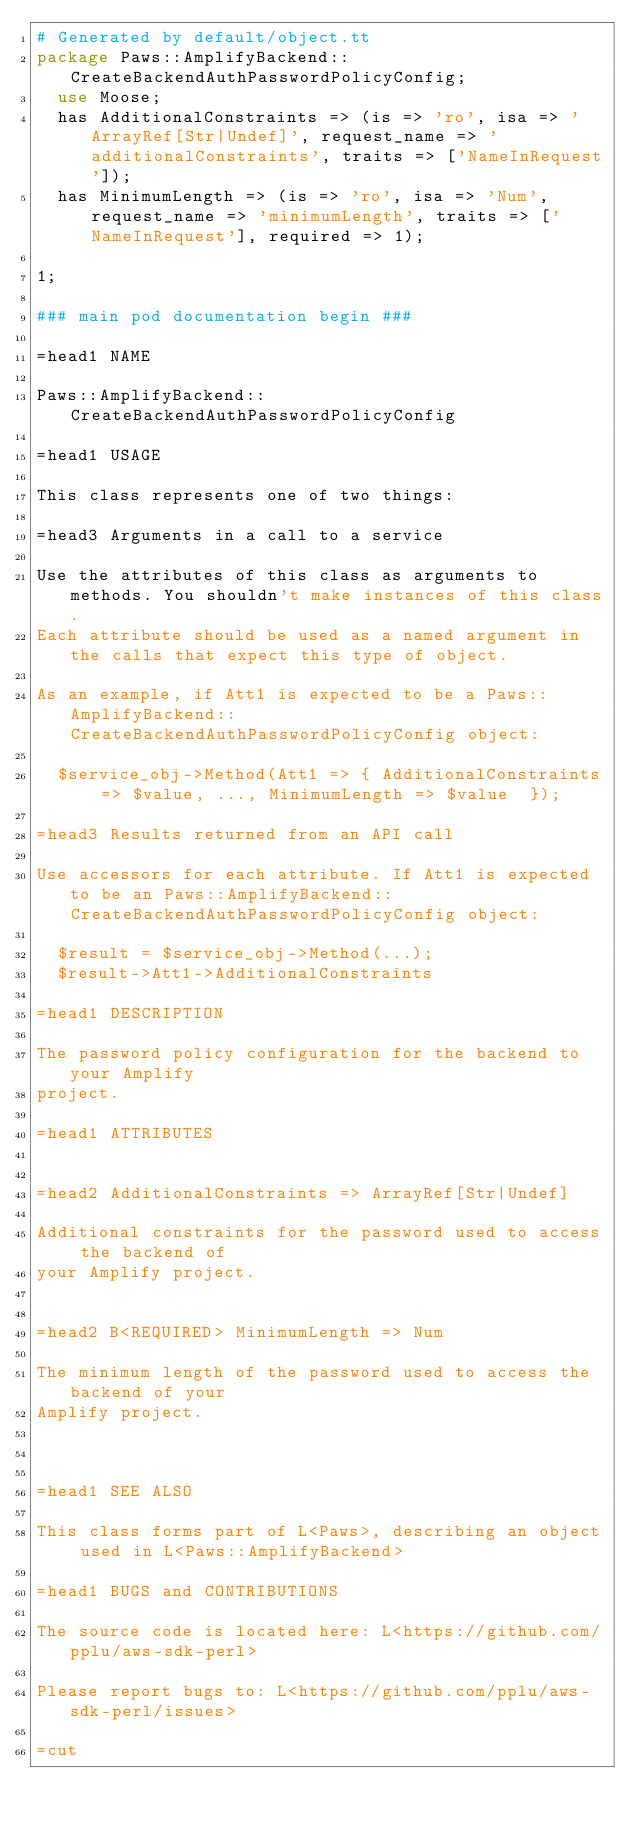<code> <loc_0><loc_0><loc_500><loc_500><_Perl_># Generated by default/object.tt
package Paws::AmplifyBackend::CreateBackendAuthPasswordPolicyConfig;
  use Moose;
  has AdditionalConstraints => (is => 'ro', isa => 'ArrayRef[Str|Undef]', request_name => 'additionalConstraints', traits => ['NameInRequest']);
  has MinimumLength => (is => 'ro', isa => 'Num', request_name => 'minimumLength', traits => ['NameInRequest'], required => 1);

1;

### main pod documentation begin ###

=head1 NAME

Paws::AmplifyBackend::CreateBackendAuthPasswordPolicyConfig

=head1 USAGE

This class represents one of two things:

=head3 Arguments in a call to a service

Use the attributes of this class as arguments to methods. You shouldn't make instances of this class. 
Each attribute should be used as a named argument in the calls that expect this type of object.

As an example, if Att1 is expected to be a Paws::AmplifyBackend::CreateBackendAuthPasswordPolicyConfig object:

  $service_obj->Method(Att1 => { AdditionalConstraints => $value, ..., MinimumLength => $value  });

=head3 Results returned from an API call

Use accessors for each attribute. If Att1 is expected to be an Paws::AmplifyBackend::CreateBackendAuthPasswordPolicyConfig object:

  $result = $service_obj->Method(...);
  $result->Att1->AdditionalConstraints

=head1 DESCRIPTION

The password policy configuration for the backend to your Amplify
project.

=head1 ATTRIBUTES


=head2 AdditionalConstraints => ArrayRef[Str|Undef]

Additional constraints for the password used to access the backend of
your Amplify project.


=head2 B<REQUIRED> MinimumLength => Num

The minimum length of the password used to access the backend of your
Amplify project.



=head1 SEE ALSO

This class forms part of L<Paws>, describing an object used in L<Paws::AmplifyBackend>

=head1 BUGS and CONTRIBUTIONS

The source code is located here: L<https://github.com/pplu/aws-sdk-perl>

Please report bugs to: L<https://github.com/pplu/aws-sdk-perl/issues>

=cut

</code> 